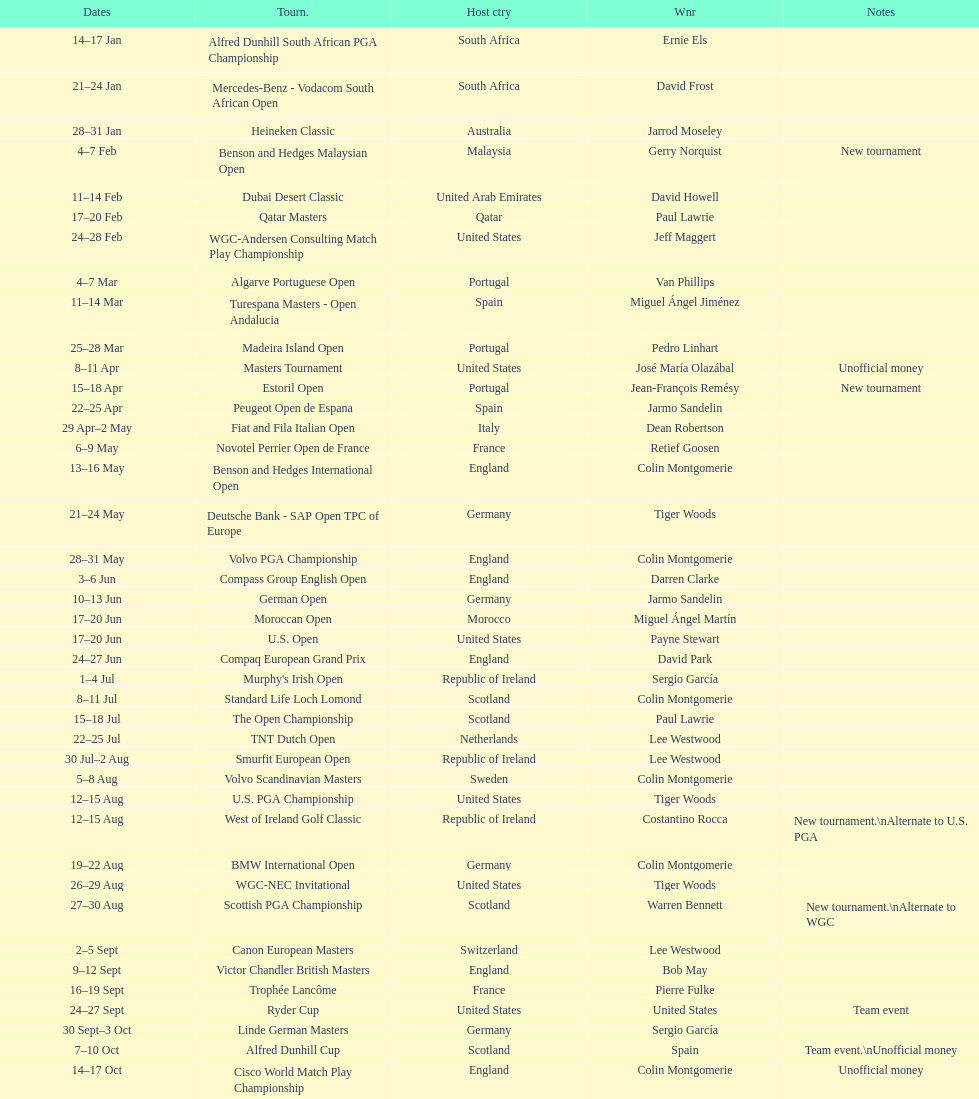Which winner won more tournaments, jeff maggert or tiger woods? Tiger Woods. 